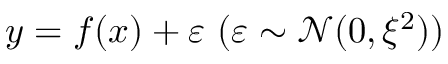Convert formula to latex. <formula><loc_0><loc_0><loc_500><loc_500>y = f ( x ) + \varepsilon \ ( \varepsilon \sim \mathcal { N } ( 0 , \xi ^ { 2 } ) )</formula> 